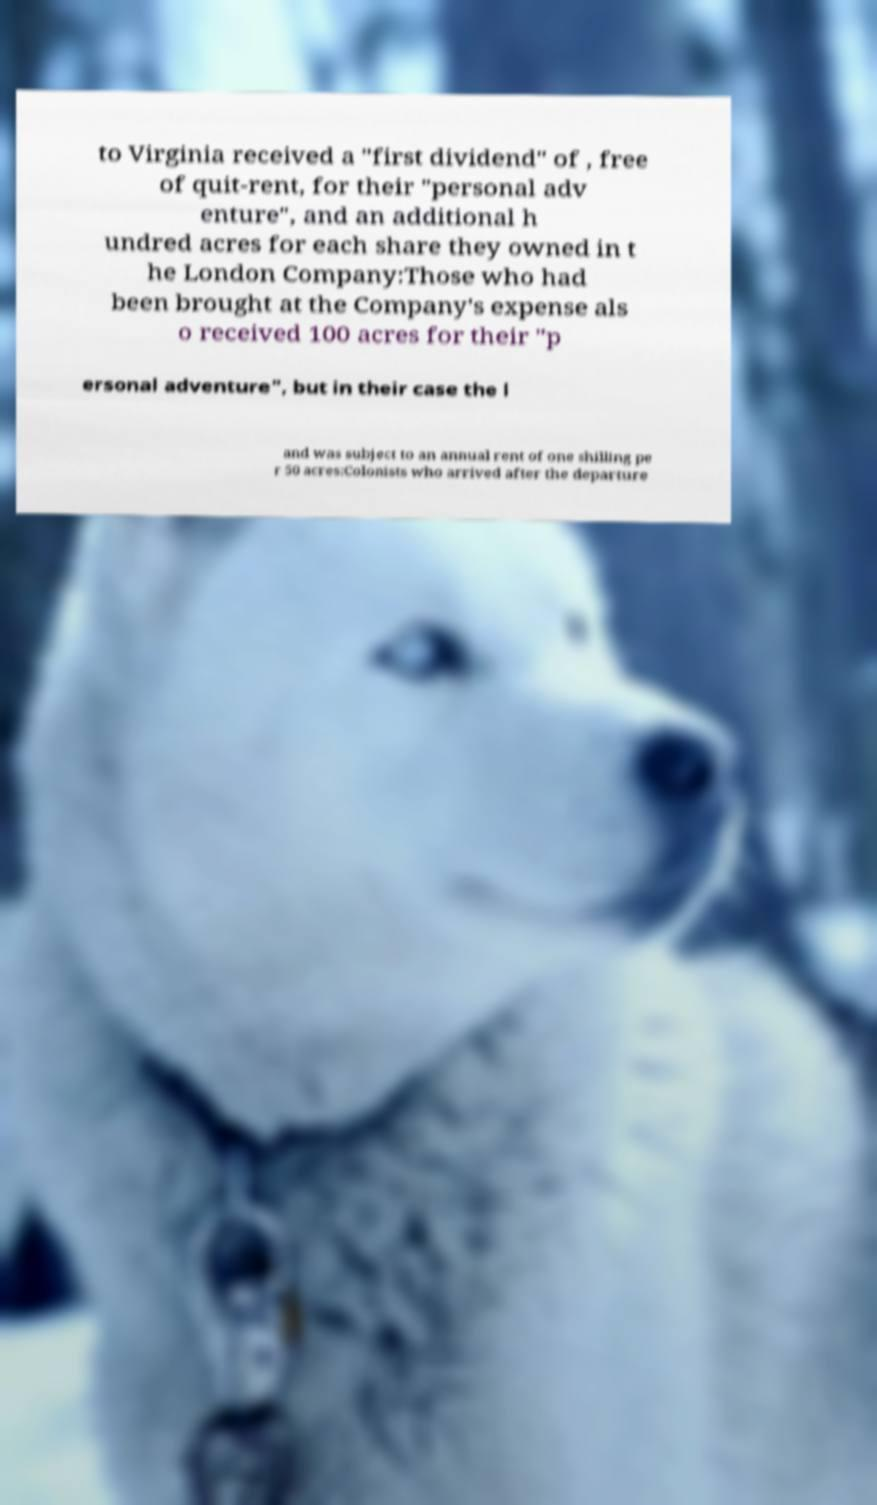I need the written content from this picture converted into text. Can you do that? to Virginia received a "first dividend" of , free of quit-rent, for their "personal adv enture", and an additional h undred acres for each share they owned in t he London Company:Those who had been brought at the Company's expense als o received 100 acres for their "p ersonal adventure", but in their case the l and was subject to an annual rent of one shilling pe r 50 acres:Colonists who arrived after the departure 